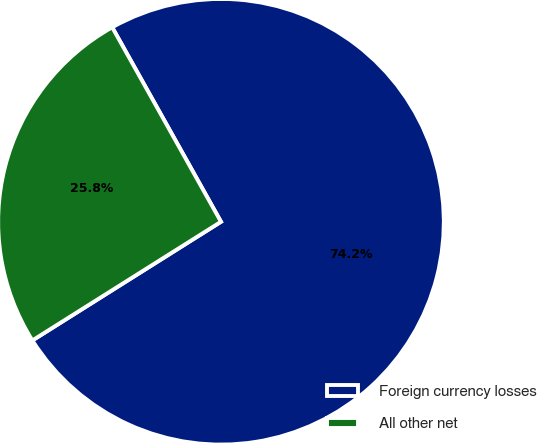<chart> <loc_0><loc_0><loc_500><loc_500><pie_chart><fcel>Foreign currency losses<fcel>All other net<nl><fcel>74.18%<fcel>25.82%<nl></chart> 